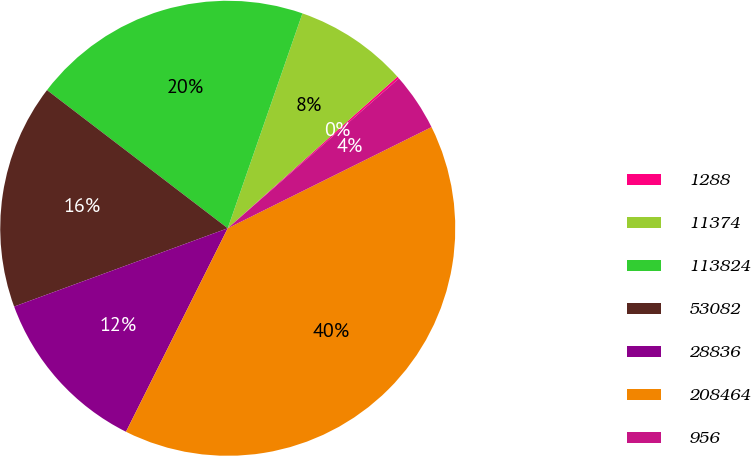Convert chart to OTSL. <chart><loc_0><loc_0><loc_500><loc_500><pie_chart><fcel>1288<fcel>11374<fcel>113824<fcel>53082<fcel>28836<fcel>208464<fcel>956<nl><fcel>0.16%<fcel>8.07%<fcel>19.94%<fcel>15.98%<fcel>12.03%<fcel>39.72%<fcel>4.11%<nl></chart> 